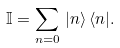Convert formula to latex. <formula><loc_0><loc_0><loc_500><loc_500>\mathbb { I } = \sum _ { n = 0 } \, | n \rangle \, \langle n | .</formula> 